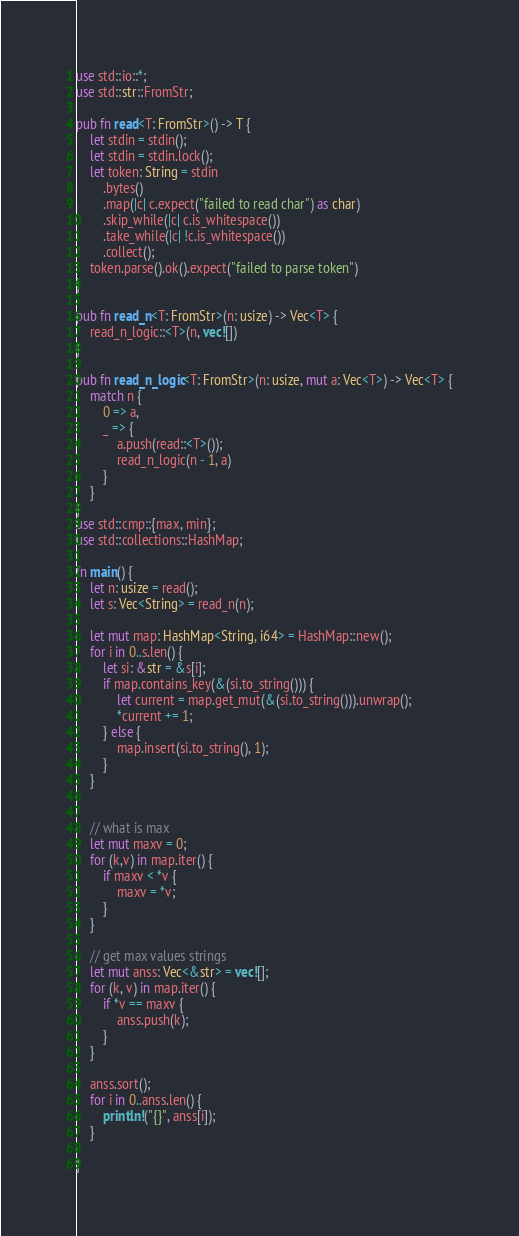Convert code to text. <code><loc_0><loc_0><loc_500><loc_500><_Rust_>use std::io::*;
use std::str::FromStr;

pub fn read<T: FromStr>() -> T {
    let stdin = stdin();
    let stdin = stdin.lock();
    let token: String = stdin
        .bytes()
        .map(|c| c.expect("failed to read char") as char)
        .skip_while(|c| c.is_whitespace())
        .take_while(|c| !c.is_whitespace())
        .collect();
    token.parse().ok().expect("failed to parse token")
}

pub fn read_n<T: FromStr>(n: usize) -> Vec<T> {
    read_n_logic::<T>(n, vec![])
}

pub fn read_n_logic<T: FromStr>(n: usize, mut a: Vec<T>) -> Vec<T> {
    match n {
        0 => a,
        _ => {
            a.push(read::<T>());
            read_n_logic(n - 1, a)
        }
    }
}
use std::cmp::{max, min};
use std::collections::HashMap;

fn main() {
    let n: usize = read();
    let s: Vec<String> = read_n(n);

    let mut map: HashMap<String, i64> = HashMap::new();
    for i in 0..s.len() {
        let si: &str = &s[i];
        if map.contains_key(&(si.to_string())) {
            let current = map.get_mut(&(si.to_string())).unwrap();
            *current += 1;
        } else {
            map.insert(si.to_string(), 1);
        }
    }


    // what is max
    let mut maxv = 0;
    for (k,v) in map.iter() {
        if maxv < *v {
            maxv = *v;
        }
    }

    // get max values strings
    let mut anss: Vec<&str> = vec![];
    for (k, v) in map.iter() {
        if *v == maxv {
            anss.push(k);
        }
    }

    anss.sort();
    for i in 0..anss.len() {
        println!("{}", anss[i]);
    }

}
</code> 